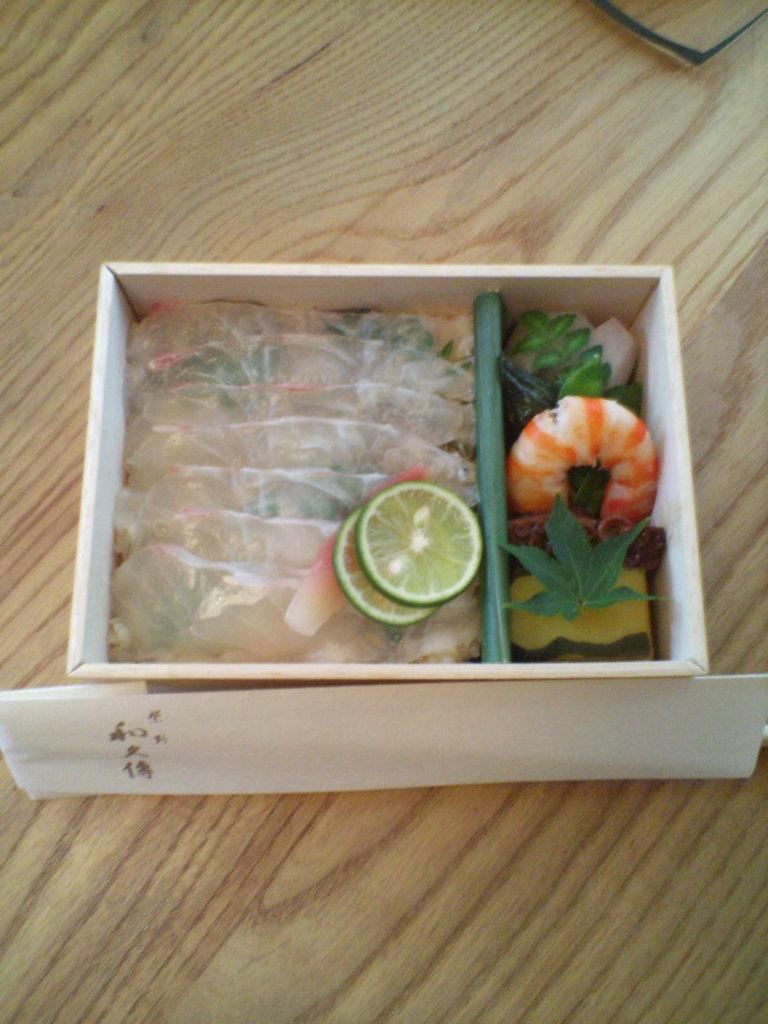What is placed on the wooden surface in the image? There is a card and a box with food on the wooden surface. Can you describe the card on the wooden surface? The card is the main object placed on the wooden surface. What type of food is in the box on the wooden surface? The facts do not specify the type of food in the box. Where is the scarecrow standing in the image? There is no scarecrow present in the image. How many farmers are visible in the image? There is no farmer present in the image. 